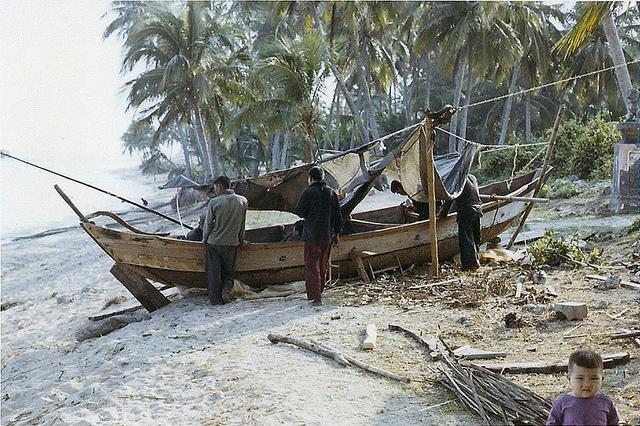What would be the most useful material for adding to the boat in this image? Please explain your reasoning. sticks. It would help hold things up 